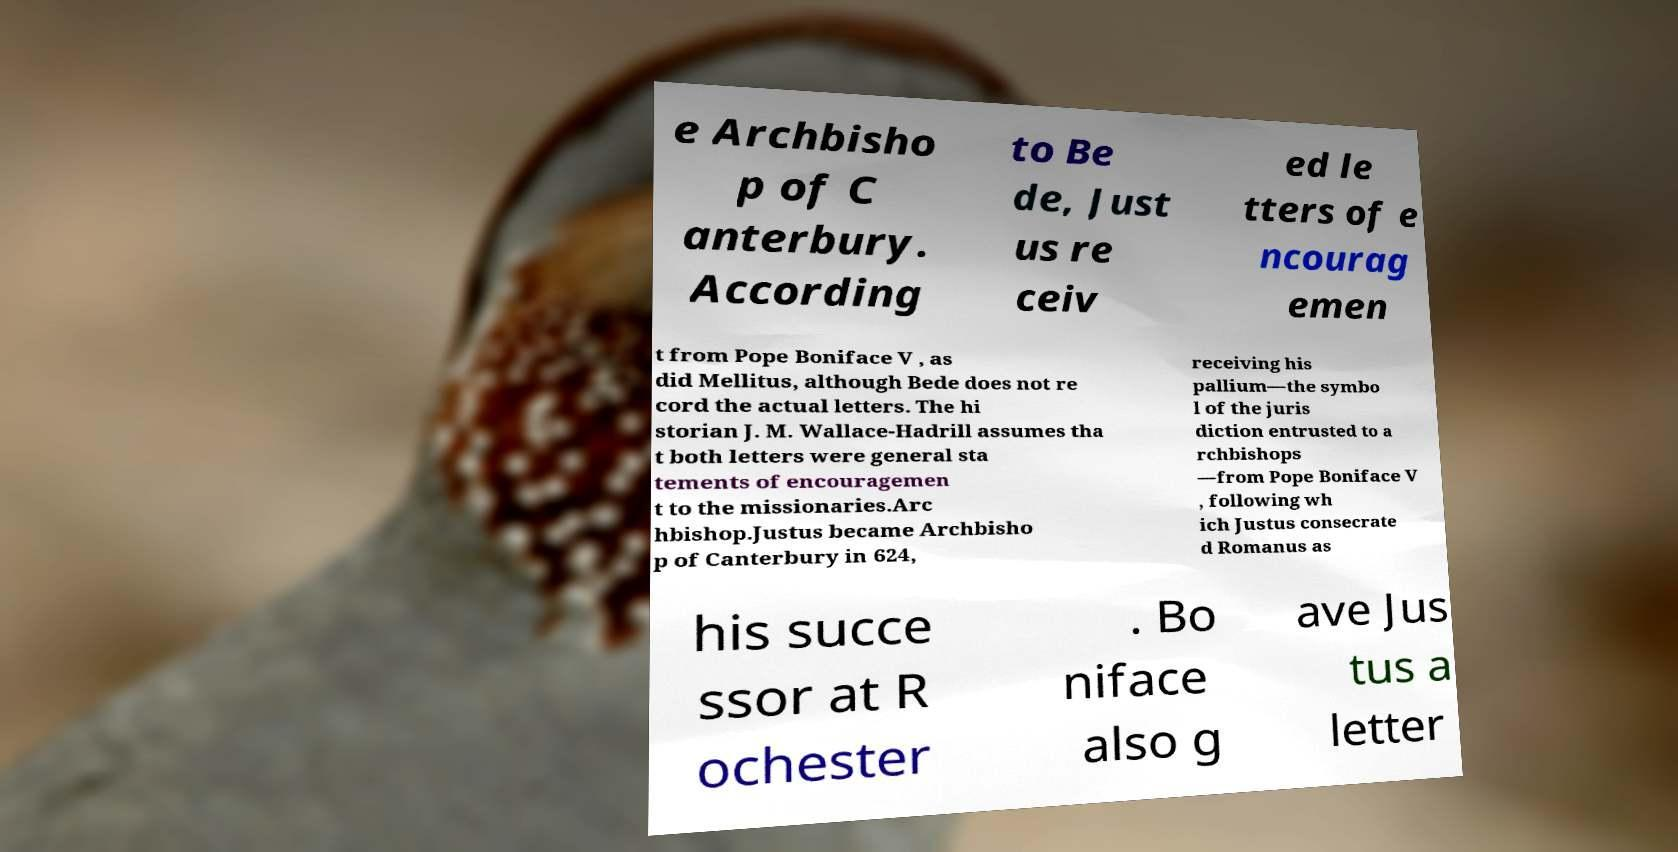Please read and relay the text visible in this image. What does it say? e Archbisho p of C anterbury. According to Be de, Just us re ceiv ed le tters of e ncourag emen t from Pope Boniface V , as did Mellitus, although Bede does not re cord the actual letters. The hi storian J. M. Wallace-Hadrill assumes tha t both letters were general sta tements of encouragemen t to the missionaries.Arc hbishop.Justus became Archbisho p of Canterbury in 624, receiving his pallium—the symbo l of the juris diction entrusted to a rchbishops —from Pope Boniface V , following wh ich Justus consecrate d Romanus as his succe ssor at R ochester . Bo niface also g ave Jus tus a letter 